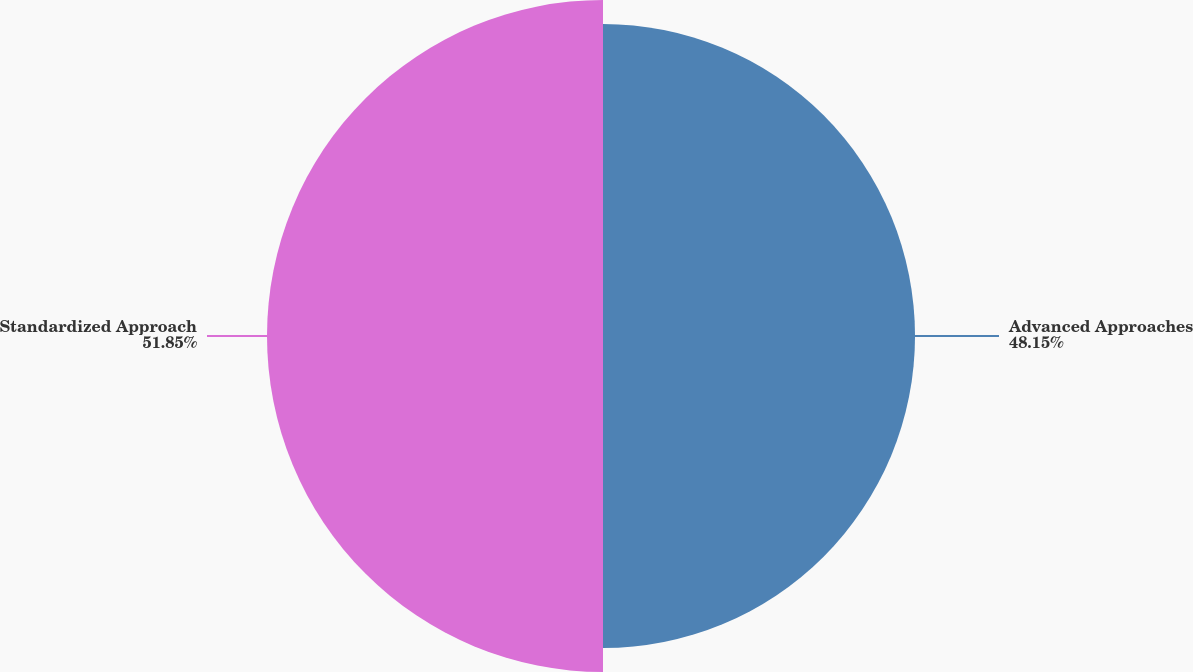<chart> <loc_0><loc_0><loc_500><loc_500><pie_chart><fcel>Advanced Approaches<fcel>Standardized Approach<nl><fcel>48.15%<fcel>51.85%<nl></chart> 